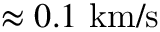Convert formula to latex. <formula><loc_0><loc_0><loc_500><loc_500>\approx 0 . 1 \ k m / s</formula> 